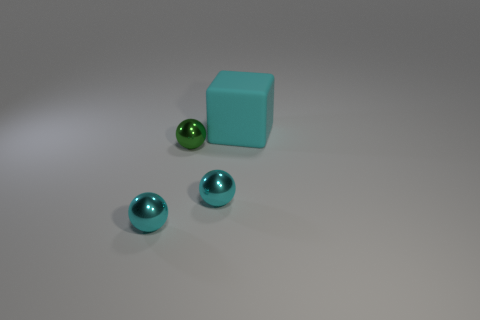Is the big rubber thing the same shape as the tiny green object?
Your answer should be very brief. No. What is the material of the large block?
Your answer should be compact. Rubber. How many objects are both right of the small green metal object and to the left of the big cyan rubber thing?
Your answer should be compact. 1. Is the size of the rubber cube the same as the green metal thing?
Offer a very short reply. No. Does the shiny sphere that is to the left of the green metal ball have the same size as the big cyan rubber thing?
Ensure brevity in your answer.  No. There is a metal ball that is to the right of the small green shiny sphere; what is its color?
Make the answer very short. Cyan. What number of balls are there?
Make the answer very short. 3. There is a shiny object on the left side of the green thing; is its color the same as the metallic sphere that is right of the green thing?
Offer a terse response. Yes. Are there an equal number of metal things behind the cyan matte block and small cyan balls?
Your answer should be very brief. No. There is a rubber thing; how many cyan things are in front of it?
Your response must be concise. 2. 